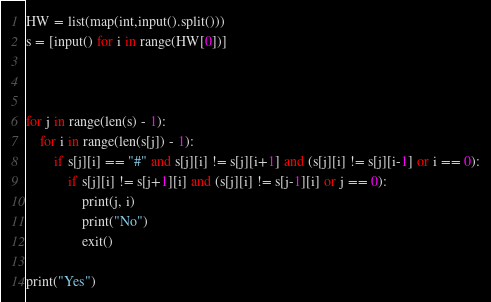Convert code to text. <code><loc_0><loc_0><loc_500><loc_500><_Python_>HW = list(map(int,input().split()))
s = [input() for i in range(HW[0])]



for j in range(len(s) - 1):
    for i in range(len(s[j]) - 1):
        if s[j][i] == "#" and s[j][i] != s[j][i+1] and (s[j][i] != s[j][i-1] or i == 0):
            if s[j][i] != s[j+1][i] and (s[j][i] != s[j-1][i] or j == 0):
                print(j, i)
                print("No")
                exit()

print("Yes")</code> 